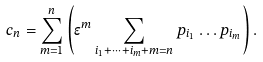Convert formula to latex. <formula><loc_0><loc_0><loc_500><loc_500>c _ { n } = \sum _ { m = 1 } ^ { n } \left ( \epsilon ^ { m } \sum _ { i _ { 1 } + \cdots + i _ { m } + m = n } p _ { i _ { 1 } } \dots p _ { i _ { m } } \right ) .</formula> 